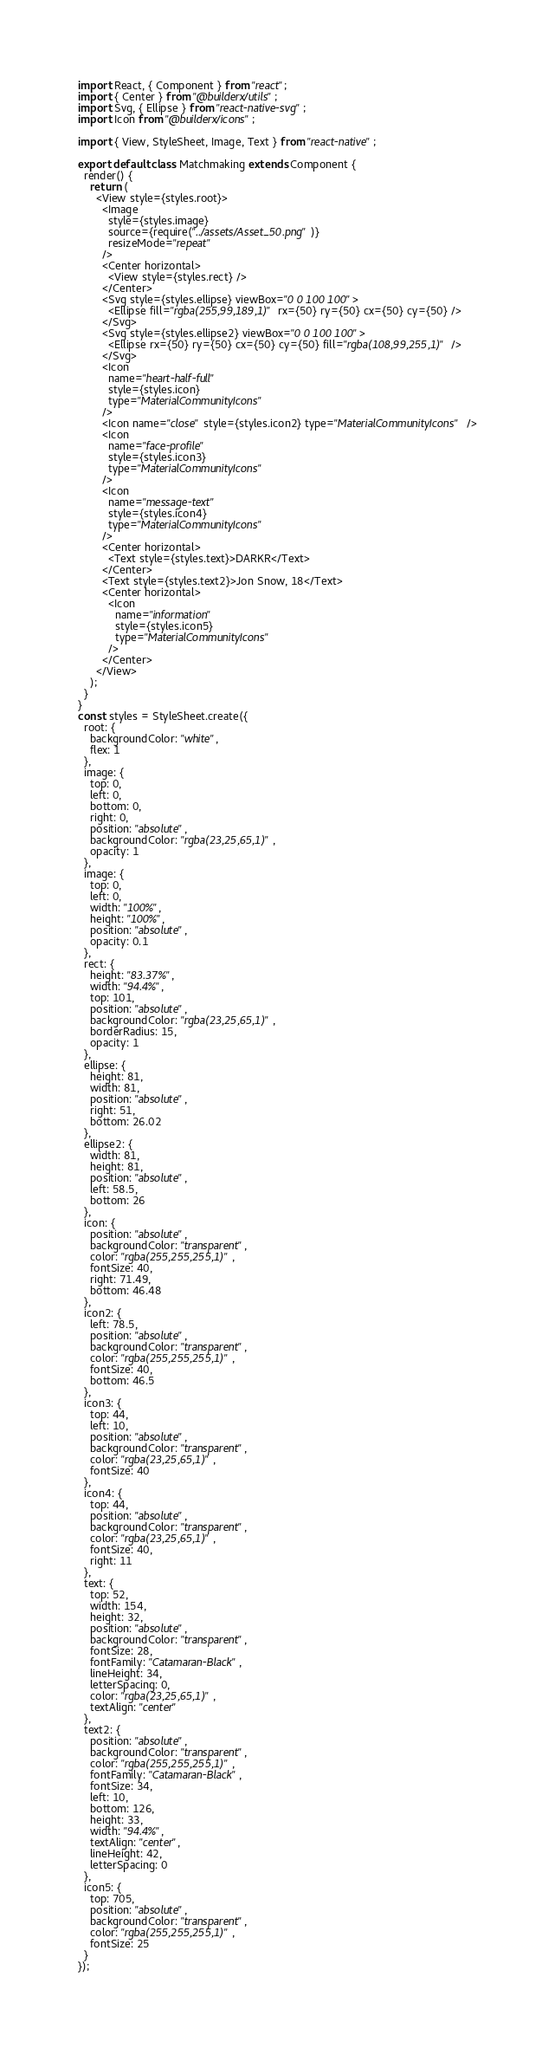<code> <loc_0><loc_0><loc_500><loc_500><_JavaScript_>import React, { Component } from "react";
import { Center } from "@builderx/utils";
import Svg, { Ellipse } from "react-native-svg";
import Icon from "@builderx/icons";

import { View, StyleSheet, Image, Text } from "react-native";

export default class Matchmaking extends Component {
  render() {
    return (
      <View style={styles.root}>
        <Image
          style={styles.image}
          source={require("../assets/Asset_50.png")}
          resizeMode="repeat"
        />
        <Center horizontal>
          <View style={styles.rect} />
        </Center>
        <Svg style={styles.ellipse} viewBox="0 0 100 100">
          <Ellipse fill="rgba(255,99,189,1)" rx={50} ry={50} cx={50} cy={50} />
        </Svg>
        <Svg style={styles.ellipse2} viewBox="0 0 100 100">
          <Ellipse rx={50} ry={50} cx={50} cy={50} fill="rgba(108,99,255,1)" />
        </Svg>
        <Icon
          name="heart-half-full"
          style={styles.icon}
          type="MaterialCommunityIcons"
        />
        <Icon name="close" style={styles.icon2} type="MaterialCommunityIcons" />
        <Icon
          name="face-profile"
          style={styles.icon3}
          type="MaterialCommunityIcons"
        />
        <Icon
          name="message-text"
          style={styles.icon4}
          type="MaterialCommunityIcons"
        />
        <Center horizontal>
          <Text style={styles.text}>DARKR</Text>
        </Center>
        <Text style={styles.text2}>Jon Snow, 18</Text>
        <Center horizontal>
          <Icon
            name="information"
            style={styles.icon5}
            type="MaterialCommunityIcons"
          />
        </Center>
      </View>
    );
  }
}
const styles = StyleSheet.create({
  root: {
    backgroundColor: "white",
    flex: 1
  },
  image: {
    top: 0,
    left: 0,
    bottom: 0,
    right: 0,
    position: "absolute",
    backgroundColor: "rgba(23,25,65,1)",
    opacity: 1
  },
  image: {
    top: 0,
    left: 0,
    width: "100%",
    height: "100%",
    position: "absolute",
    opacity: 0.1
  },
  rect: {
    height: "83.37%",
    width: "94.4%",
    top: 101,
    position: "absolute",
    backgroundColor: "rgba(23,25,65,1)",
    borderRadius: 15,
    opacity: 1
  },
  ellipse: {
    height: 81,
    width: 81,
    position: "absolute",
    right: 51,
    bottom: 26.02
  },
  ellipse2: {
    width: 81,
    height: 81,
    position: "absolute",
    left: 58.5,
    bottom: 26
  },
  icon: {
    position: "absolute",
    backgroundColor: "transparent",
    color: "rgba(255,255,255,1)",
    fontSize: 40,
    right: 71.49,
    bottom: 46.48
  },
  icon2: {
    left: 78.5,
    position: "absolute",
    backgroundColor: "transparent",
    color: "rgba(255,255,255,1)",
    fontSize: 40,
    bottom: 46.5
  },
  icon3: {
    top: 44,
    left: 10,
    position: "absolute",
    backgroundColor: "transparent",
    color: "rgba(23,25,65,1)",
    fontSize: 40
  },
  icon4: {
    top: 44,
    position: "absolute",
    backgroundColor: "transparent",
    color: "rgba(23,25,65,1)",
    fontSize: 40,
    right: 11
  },
  text: {
    top: 52,
    width: 154,
    height: 32,
    position: "absolute",
    backgroundColor: "transparent",
    fontSize: 28,
    fontFamily: "Catamaran-Black",
    lineHeight: 34,
    letterSpacing: 0,
    color: "rgba(23,25,65,1)",
    textAlign: "center"
  },
  text2: {
    position: "absolute",
    backgroundColor: "transparent",
    color: "rgba(255,255,255,1)",
    fontFamily: "Catamaran-Black",
    fontSize: 34,
    left: 10,
    bottom: 126,
    height: 33,
    width: "94.4%",
    textAlign: "center",
    lineHeight: 42,
    letterSpacing: 0
  },
  icon5: {
    top: 705,
    position: "absolute",
    backgroundColor: "transparent",
    color: "rgba(255,255,255,1)",
    fontSize: 25
  }
});
</code> 